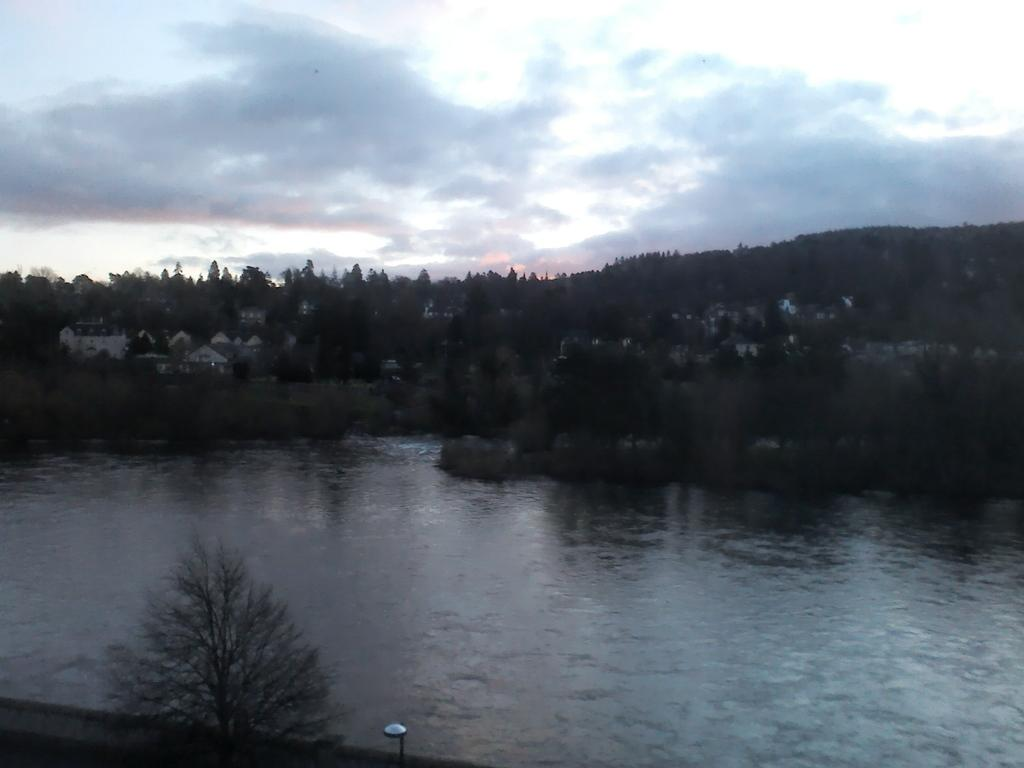What is located at the front of the image? There is water in the front of the image. What can be seen in the background of the image? There are trees in the background of the image. How would you describe the sky in the image? The sky is cloudy in the image. What is the position of the pin in the image? There is no pin present in the image. Is there a street visible in the image? The image does not show a street; it features water in the front and trees in the background. 